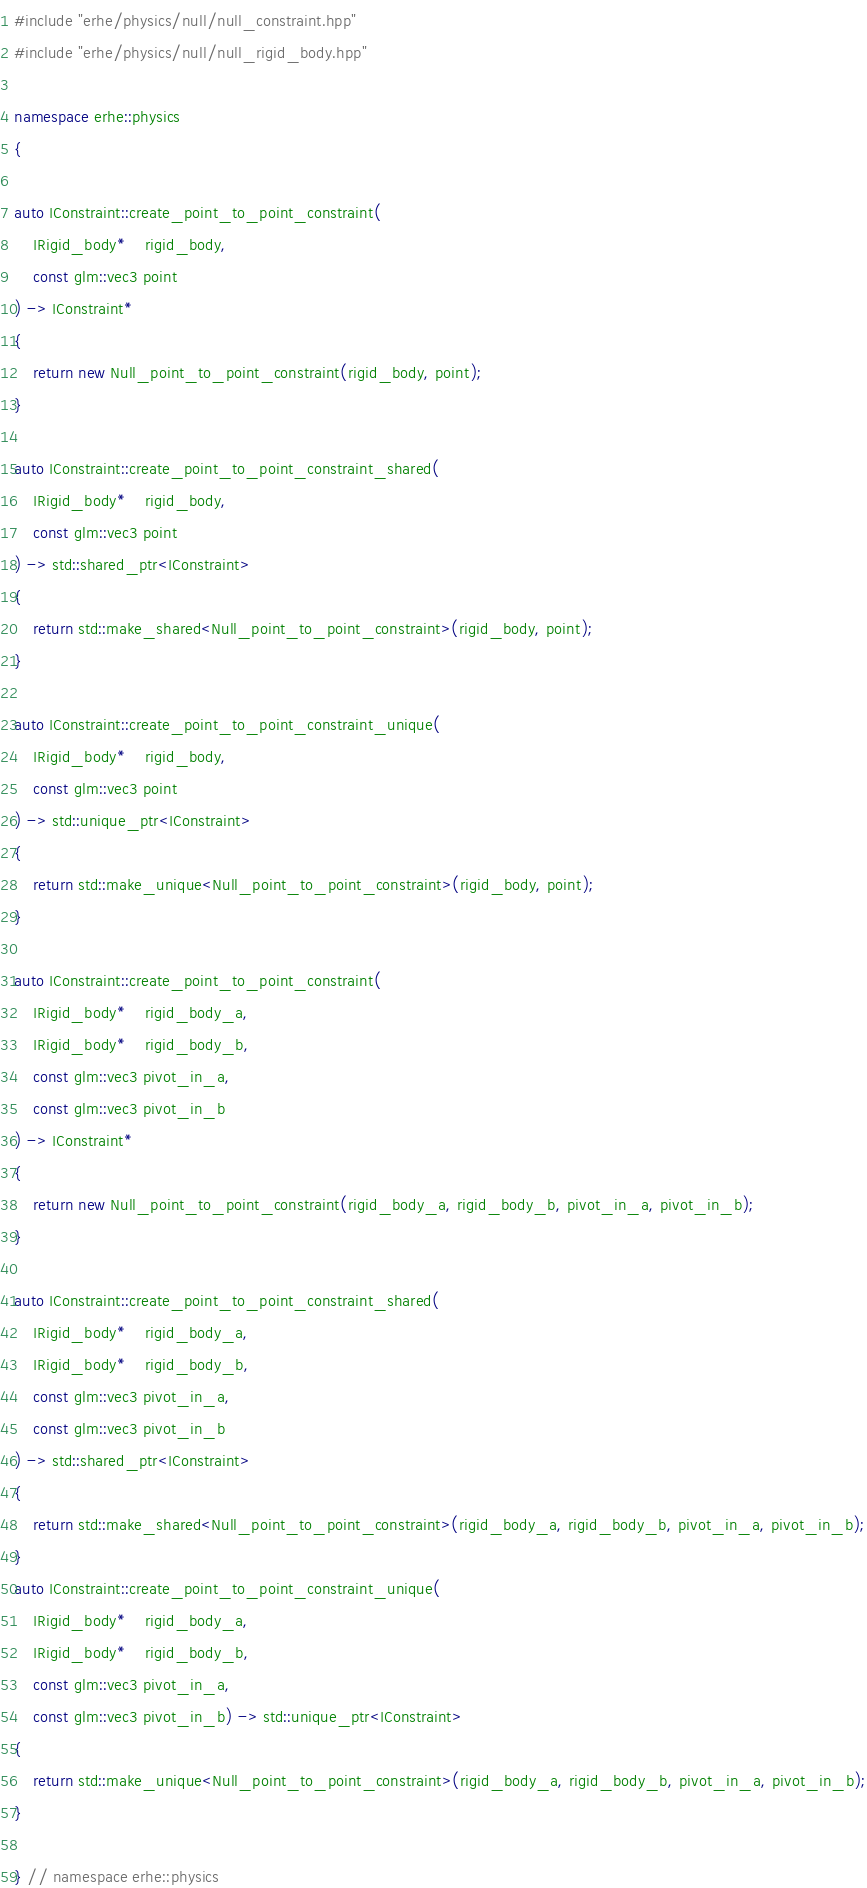<code> <loc_0><loc_0><loc_500><loc_500><_C++_>#include "erhe/physics/null/null_constraint.hpp"
#include "erhe/physics/null/null_rigid_body.hpp"

namespace erhe::physics
{

auto IConstraint::create_point_to_point_constraint(
    IRigid_body*    rigid_body,
    const glm::vec3 point
) -> IConstraint*
{
    return new Null_point_to_point_constraint(rigid_body, point);
}

auto IConstraint::create_point_to_point_constraint_shared(
    IRigid_body*    rigid_body,
    const glm::vec3 point
) -> std::shared_ptr<IConstraint>
{
    return std::make_shared<Null_point_to_point_constraint>(rigid_body, point);
}

auto IConstraint::create_point_to_point_constraint_unique(
    IRigid_body*    rigid_body,
    const glm::vec3 point
) -> std::unique_ptr<IConstraint>
{
    return std::make_unique<Null_point_to_point_constraint>(rigid_body, point);
}

auto IConstraint::create_point_to_point_constraint(
    IRigid_body*    rigid_body_a,
    IRigid_body*    rigid_body_b,
    const glm::vec3 pivot_in_a,
    const glm::vec3 pivot_in_b
) -> IConstraint*
{
    return new Null_point_to_point_constraint(rigid_body_a, rigid_body_b, pivot_in_a, pivot_in_b);
}

auto IConstraint::create_point_to_point_constraint_shared(
    IRigid_body*    rigid_body_a,
    IRigid_body*    rigid_body_b,
    const glm::vec3 pivot_in_a,
    const glm::vec3 pivot_in_b
) -> std::shared_ptr<IConstraint>
{
    return std::make_shared<Null_point_to_point_constraint>(rigid_body_a, rigid_body_b, pivot_in_a, pivot_in_b);
}
auto IConstraint::create_point_to_point_constraint_unique(
    IRigid_body*    rigid_body_a,
    IRigid_body*    rigid_body_b, 
    const glm::vec3 pivot_in_a,
    const glm::vec3 pivot_in_b) -> std::unique_ptr<IConstraint>
{
    return std::make_unique<Null_point_to_point_constraint>(rigid_body_a, rigid_body_b, pivot_in_a, pivot_in_b);
}

} // namespace erhe::physics
</code> 